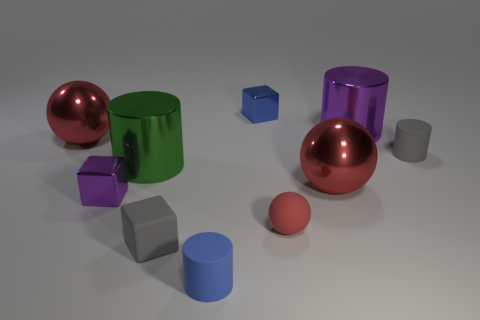Subtract all spheres. How many objects are left? 7 Add 4 blue metal objects. How many blue metal objects exist? 5 Subtract 0 blue spheres. How many objects are left? 10 Subtract all small spheres. Subtract all big cylinders. How many objects are left? 7 Add 8 metal blocks. How many metal blocks are left? 10 